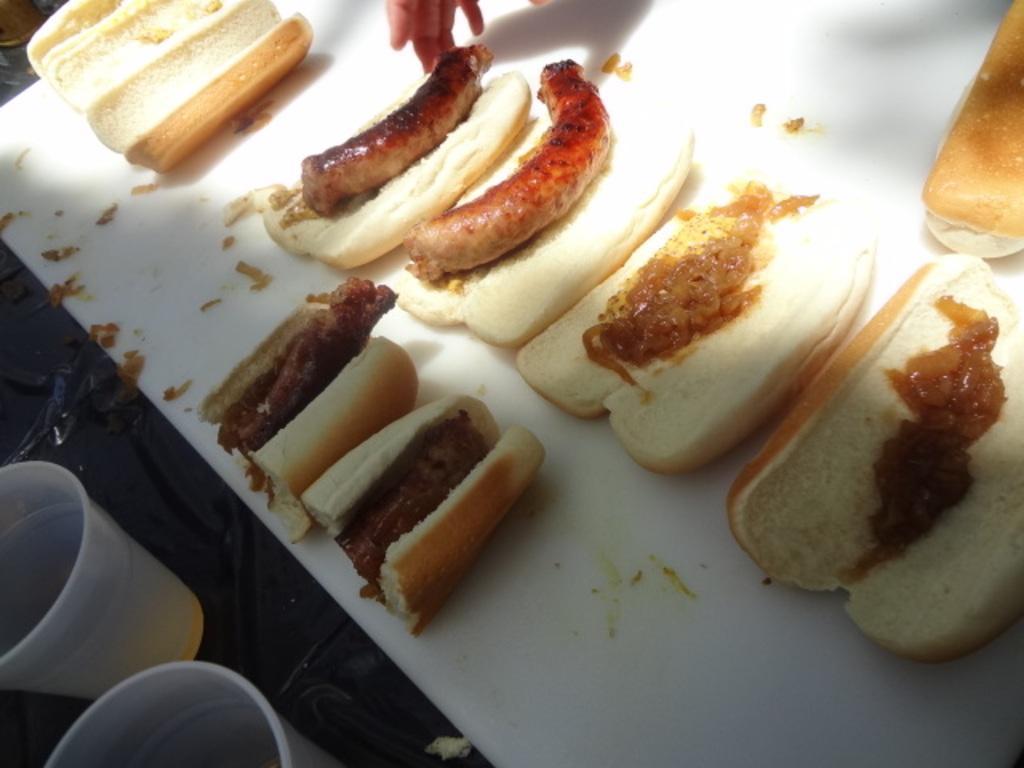Describe this image in one or two sentences. There are hot dogs arranged on the white color sheet near two glasses on the table and near hand of person. 